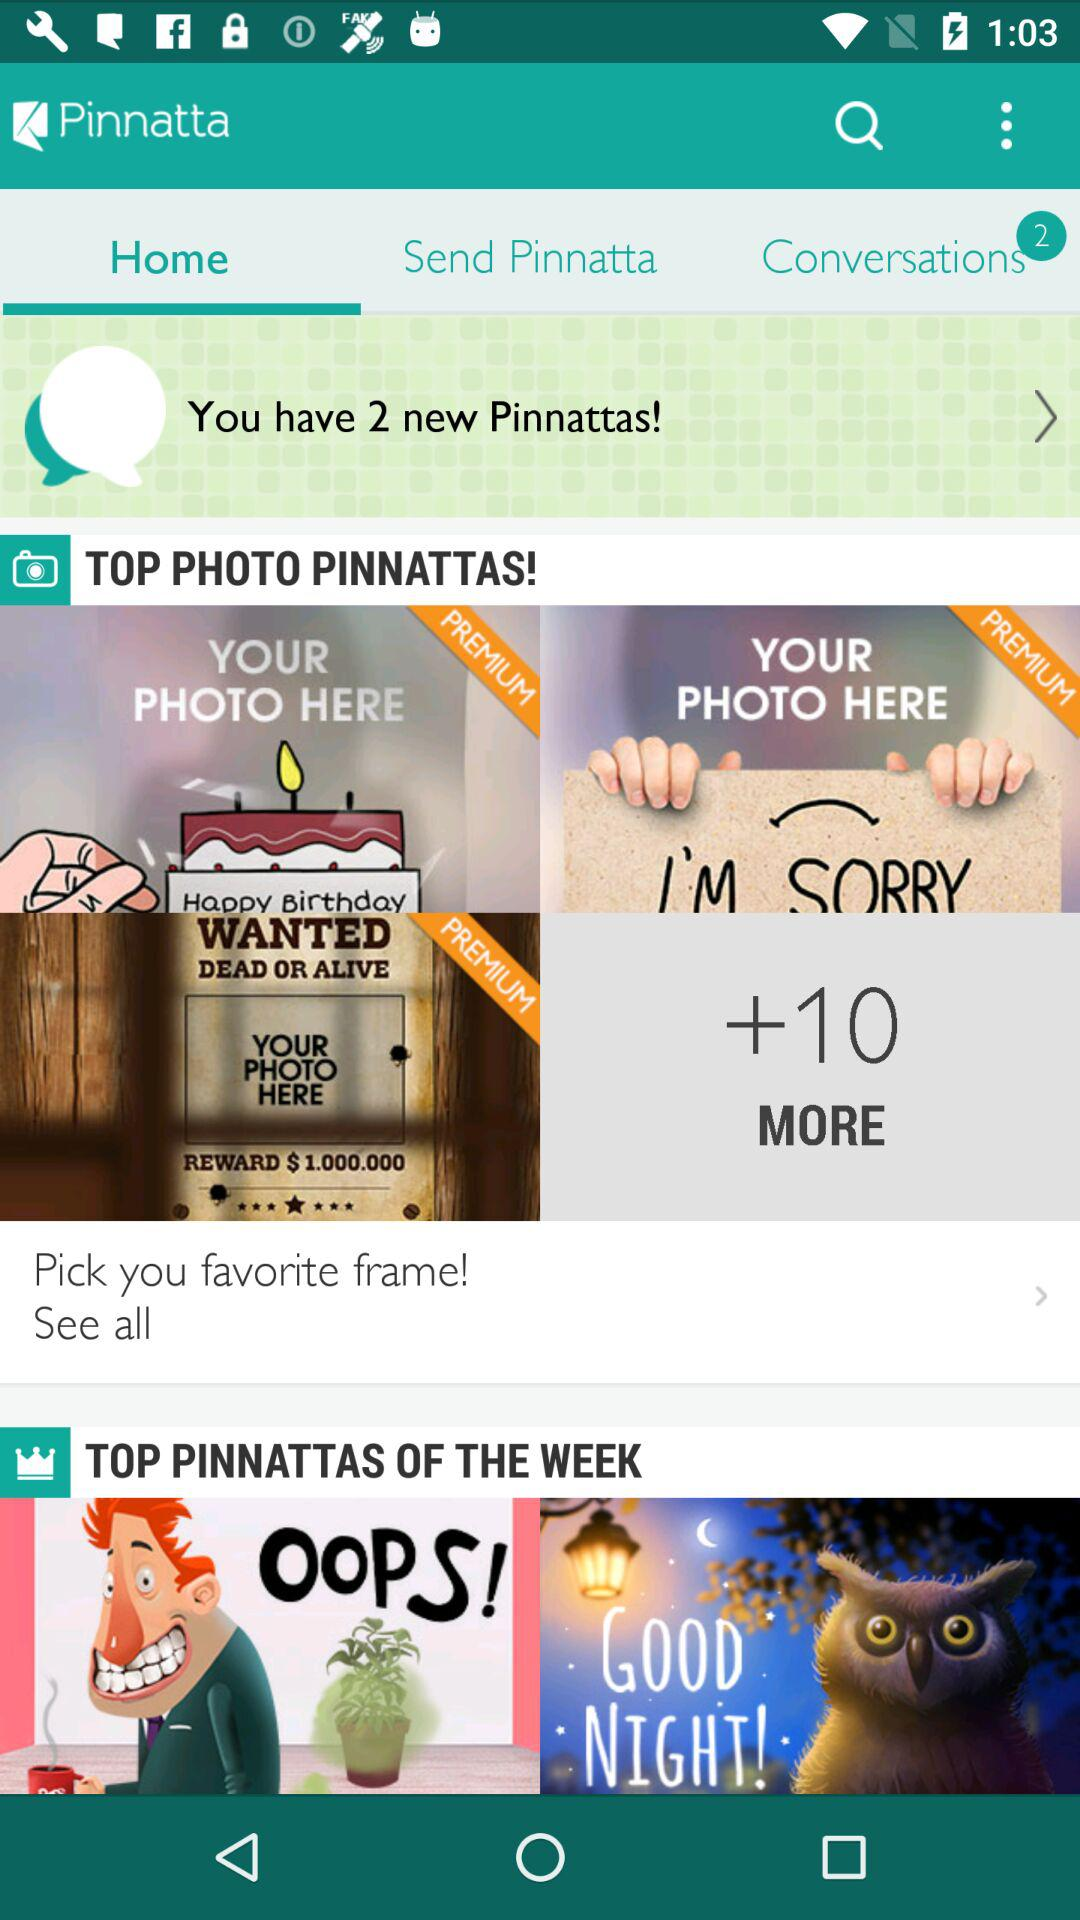What's the number of new "Pinnattas"? The number of new "Pinnattas" is 2. 